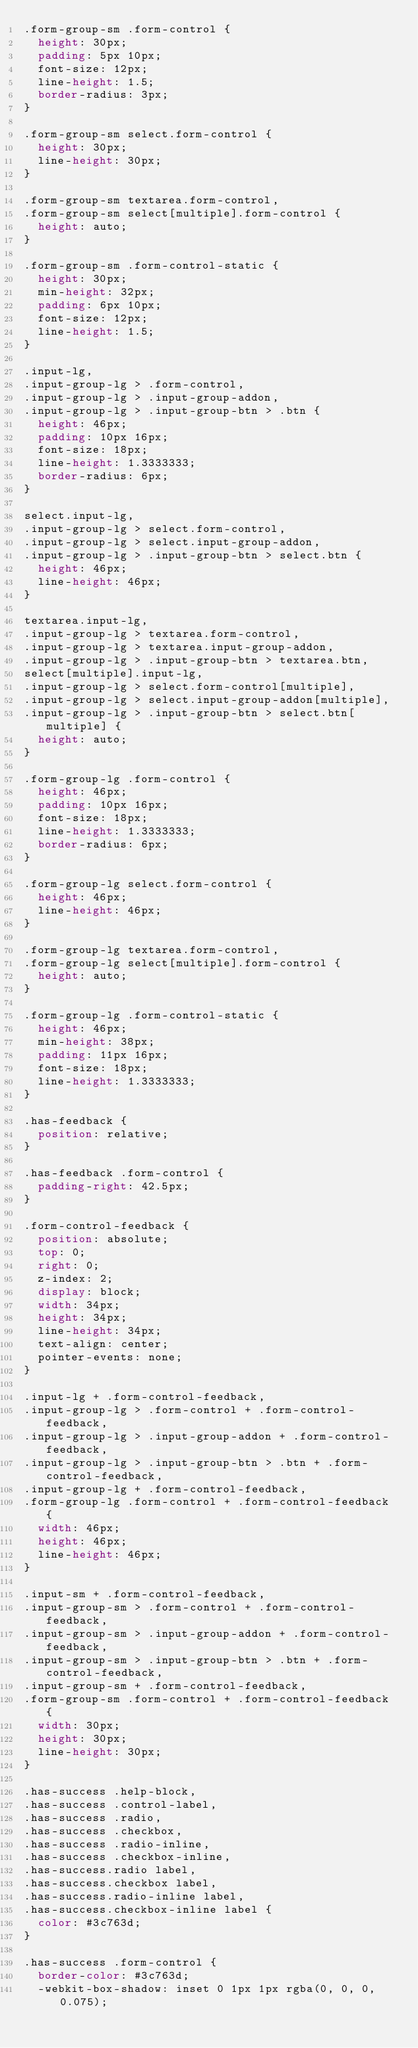<code> <loc_0><loc_0><loc_500><loc_500><_CSS_>.form-group-sm .form-control {
  height: 30px;
  padding: 5px 10px;
  font-size: 12px;
  line-height: 1.5;
  border-radius: 3px;
}

.form-group-sm select.form-control {
  height: 30px;
  line-height: 30px;
}

.form-group-sm textarea.form-control,
.form-group-sm select[multiple].form-control {
  height: auto;
}

.form-group-sm .form-control-static {
  height: 30px;
  min-height: 32px;
  padding: 6px 10px;
  font-size: 12px;
  line-height: 1.5;
}

.input-lg,
.input-group-lg > .form-control,
.input-group-lg > .input-group-addon,
.input-group-lg > .input-group-btn > .btn {
  height: 46px;
  padding: 10px 16px;
  font-size: 18px;
  line-height: 1.3333333;
  border-radius: 6px;
}

select.input-lg,
.input-group-lg > select.form-control,
.input-group-lg > select.input-group-addon,
.input-group-lg > .input-group-btn > select.btn {
  height: 46px;
  line-height: 46px;
}

textarea.input-lg,
.input-group-lg > textarea.form-control,
.input-group-lg > textarea.input-group-addon,
.input-group-lg > .input-group-btn > textarea.btn,
select[multiple].input-lg,
.input-group-lg > select.form-control[multiple],
.input-group-lg > select.input-group-addon[multiple],
.input-group-lg > .input-group-btn > select.btn[multiple] {
  height: auto;
}

.form-group-lg .form-control {
  height: 46px;
  padding: 10px 16px;
  font-size: 18px;
  line-height: 1.3333333;
  border-radius: 6px;
}

.form-group-lg select.form-control {
  height: 46px;
  line-height: 46px;
}

.form-group-lg textarea.form-control,
.form-group-lg select[multiple].form-control {
  height: auto;
}

.form-group-lg .form-control-static {
  height: 46px;
  min-height: 38px;
  padding: 11px 16px;
  font-size: 18px;
  line-height: 1.3333333;
}

.has-feedback {
  position: relative;
}

.has-feedback .form-control {
  padding-right: 42.5px;
}

.form-control-feedback {
  position: absolute;
  top: 0;
  right: 0;
  z-index: 2;
  display: block;
  width: 34px;
  height: 34px;
  line-height: 34px;
  text-align: center;
  pointer-events: none;
}

.input-lg + .form-control-feedback,
.input-group-lg > .form-control + .form-control-feedback,
.input-group-lg > .input-group-addon + .form-control-feedback,
.input-group-lg > .input-group-btn > .btn + .form-control-feedback,
.input-group-lg + .form-control-feedback,
.form-group-lg .form-control + .form-control-feedback {
  width: 46px;
  height: 46px;
  line-height: 46px;
}

.input-sm + .form-control-feedback,
.input-group-sm > .form-control + .form-control-feedback,
.input-group-sm > .input-group-addon + .form-control-feedback,
.input-group-sm > .input-group-btn > .btn + .form-control-feedback,
.input-group-sm + .form-control-feedback,
.form-group-sm .form-control + .form-control-feedback {
  width: 30px;
  height: 30px;
  line-height: 30px;
}

.has-success .help-block,
.has-success .control-label,
.has-success .radio,
.has-success .checkbox,
.has-success .radio-inline,
.has-success .checkbox-inline,
.has-success.radio label,
.has-success.checkbox label,
.has-success.radio-inline label,
.has-success.checkbox-inline label {
  color: #3c763d;
}

.has-success .form-control {
  border-color: #3c763d;
  -webkit-box-shadow: inset 0 1px 1px rgba(0, 0, 0, 0.075);</code> 